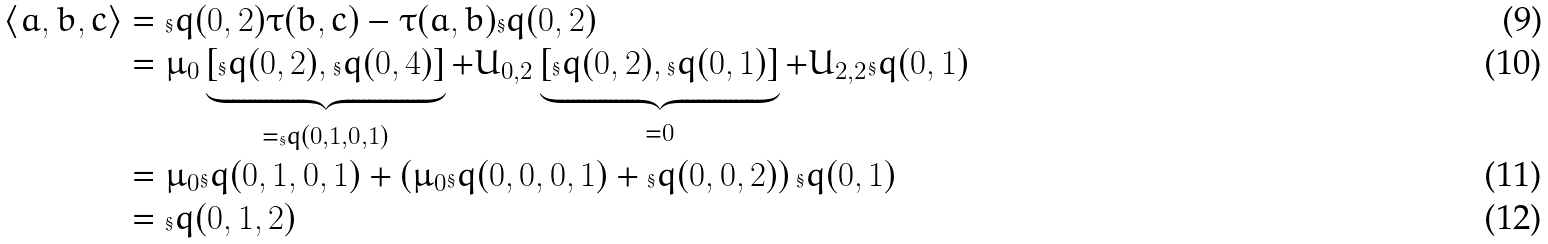<formula> <loc_0><loc_0><loc_500><loc_500>\langle a , b , c \rangle & = \S q ( 0 , 2 ) \tau ( b , c ) - \tau ( a , b ) \S q ( 0 , 2 ) \\ & = \mu _ { 0 } \underbrace { \left [ \S q ( 0 , 2 ) , \S q ( 0 , 4 ) \right ] } _ { = \S q ( 0 , 1 , 0 , 1 ) } + U _ { 0 , 2 } \underbrace { \left [ \S q ( 0 , 2 ) , \S q ( 0 , 1 ) \right ] } _ { = 0 } + U _ { 2 , 2 } \S q ( 0 , 1 ) \\ & = \mu _ { 0 } \S q ( 0 , 1 , 0 , 1 ) + \left ( \mu _ { 0 } \S q ( 0 , 0 , 0 , 1 ) + \S q ( 0 , 0 , 2 ) \right ) \S q ( 0 , 1 ) \\ & = \S q ( 0 , 1 , 2 )</formula> 